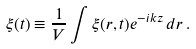<formula> <loc_0><loc_0><loc_500><loc_500>\xi ( t ) \equiv \frac { 1 } { V } \int \xi ( { r } , t ) e ^ { - i k z } \, d { r } \, .</formula> 